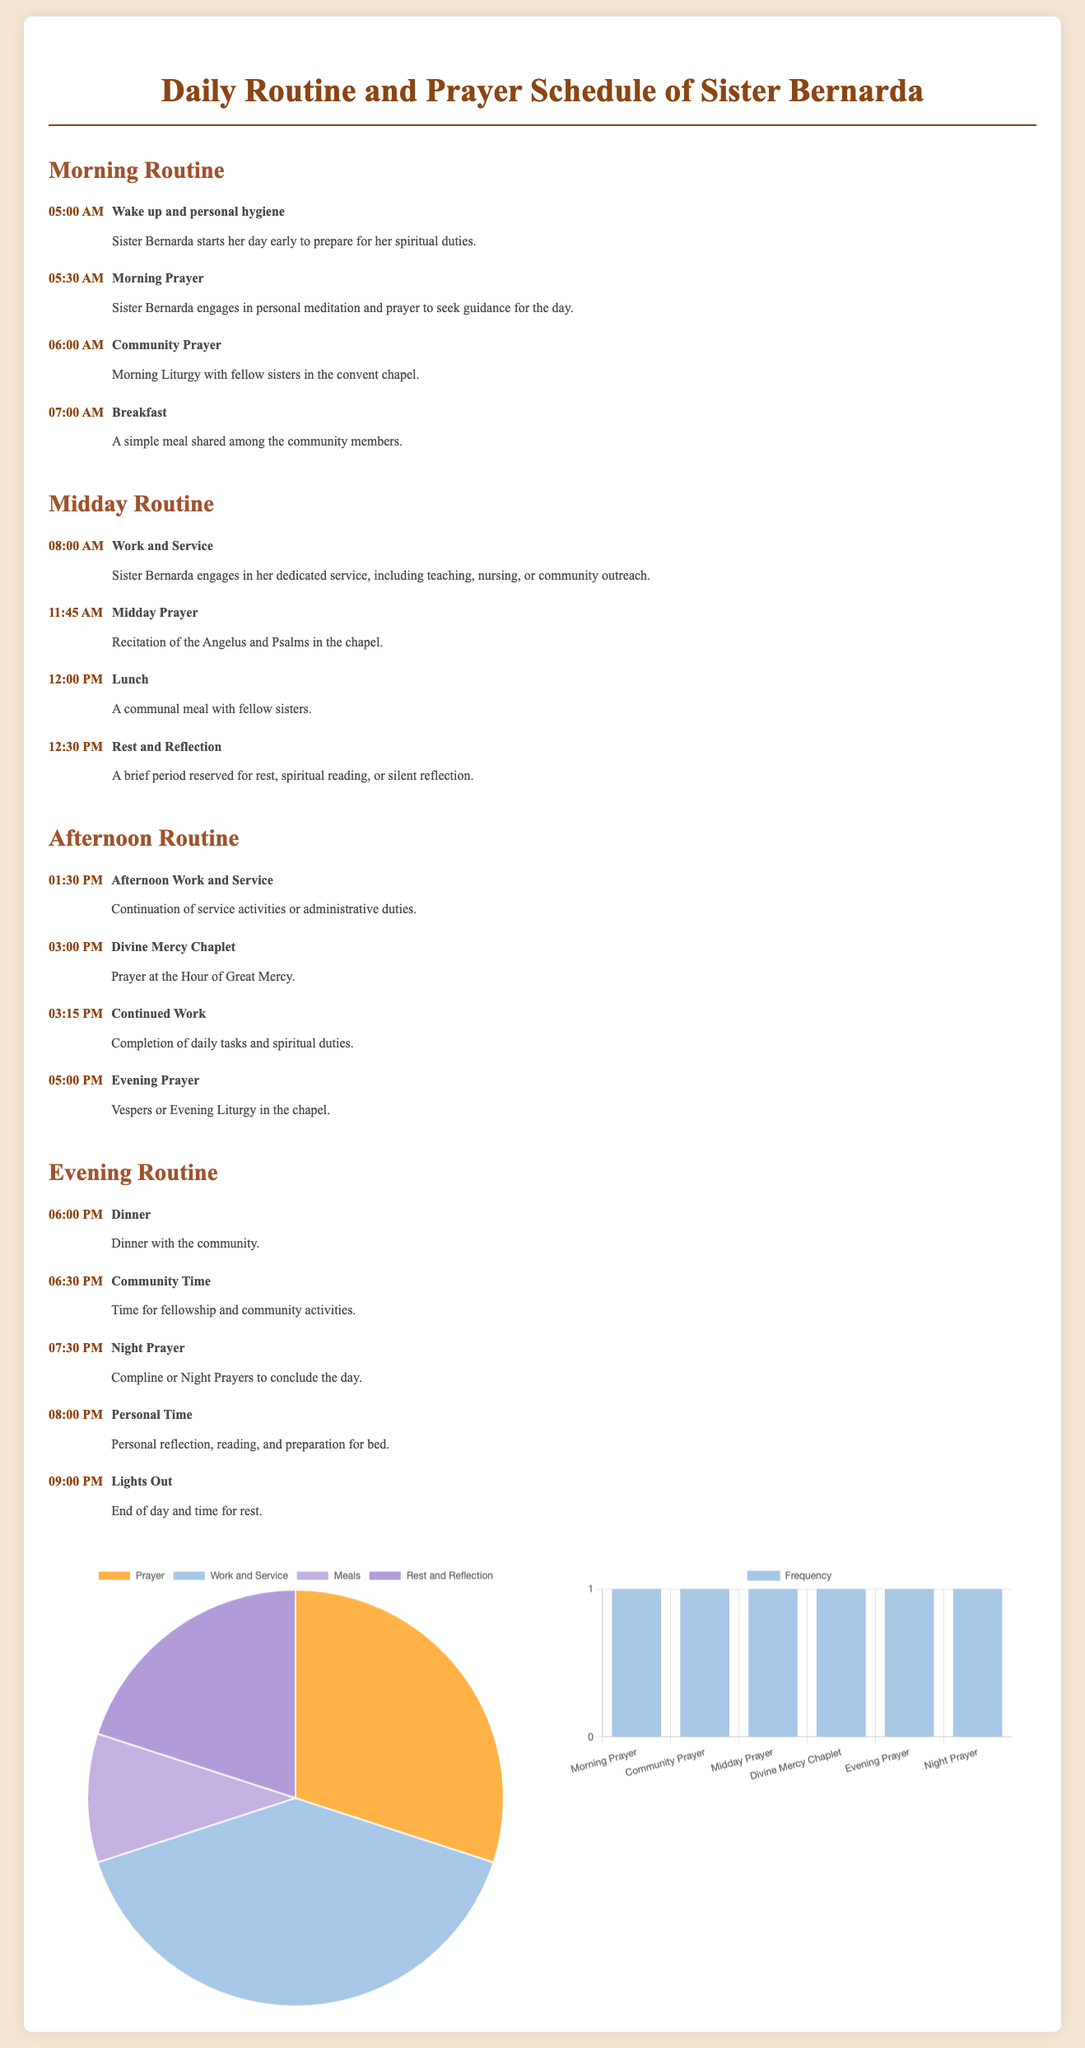What time does Sister Bernarda wake up? The wake-up time is clearly stated in the morning routine section.
Answer: 05:00 AM What activity follows Morning Prayer? The timeline order indicates the next activity after Morning Prayer.
Answer: Community Prayer How many total prayer sessions does Sister Bernarda have in a day? The prayer sessions listed include Morning Prayer, Community Prayer, Midday Prayer, Divine Mercy Chaplet, Evening Prayer, and Night Prayer.
Answer: 6 What is the percentage of time spent on Work and Service? The pie chart shows the distribution of daily activities, including the specific percentage for Work and Service.
Answer: 40 What is the last activity of the day for Sister Bernarda? The evening routine section specifies the concluding activity of the day.
Answer: Lights Out What time does Sister Bernarda have dinner? The timeline details the specific time allocated for dinner in the evening routine.
Answer: 06:00 PM How often does Sister Bernarda engage in Rest and Reflection? The frequency chart shows that Rest and Reflection is scheduled once daily.
Answer: 1 time What color represents Meals in the pie chart? The pie chart differentiates activities using specific colors.
Answer: Purple How long is the time designated for personal reflection before bed? The evening routine informs the time allocated for personal reflection.
Answer: Half an hour 